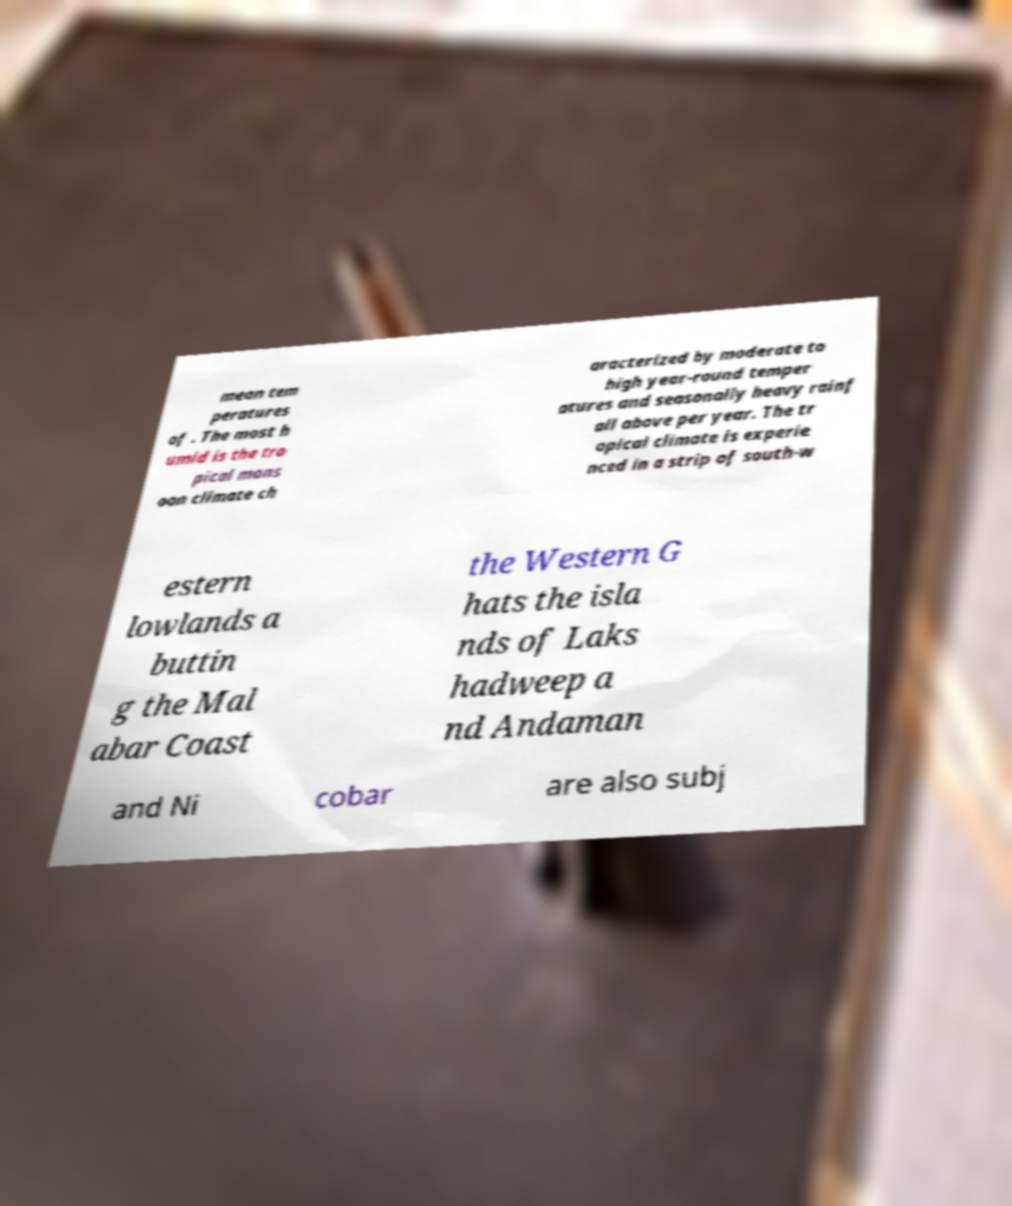For documentation purposes, I need the text within this image transcribed. Could you provide that? mean tem peratures of . The most h umid is the tro pical mons oon climate ch aracterized by moderate to high year-round temper atures and seasonally heavy rainf all above per year. The tr opical climate is experie nced in a strip of south-w estern lowlands a buttin g the Mal abar Coast the Western G hats the isla nds of Laks hadweep a nd Andaman and Ni cobar are also subj 